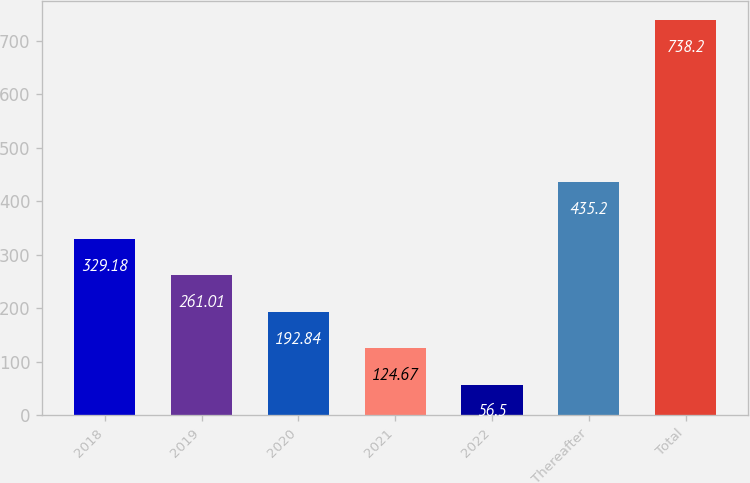Convert chart. <chart><loc_0><loc_0><loc_500><loc_500><bar_chart><fcel>2018<fcel>2019<fcel>2020<fcel>2021<fcel>2022<fcel>Thereafter<fcel>Total<nl><fcel>329.18<fcel>261.01<fcel>192.84<fcel>124.67<fcel>56.5<fcel>435.2<fcel>738.2<nl></chart> 